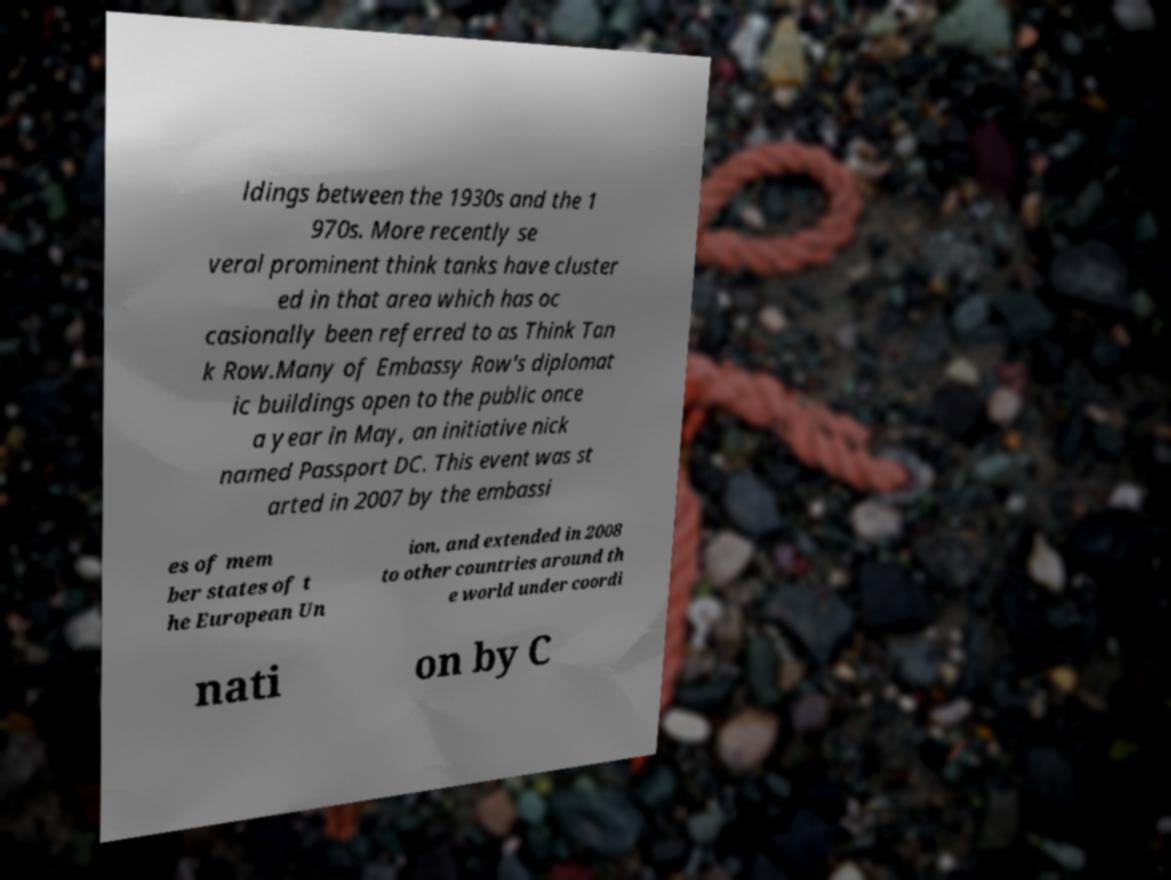For documentation purposes, I need the text within this image transcribed. Could you provide that? ldings between the 1930s and the 1 970s. More recently se veral prominent think tanks have cluster ed in that area which has oc casionally been referred to as Think Tan k Row.Many of Embassy Row's diplomat ic buildings open to the public once a year in May, an initiative nick named Passport DC. This event was st arted in 2007 by the embassi es of mem ber states of t he European Un ion, and extended in 2008 to other countries around th e world under coordi nati on by C 